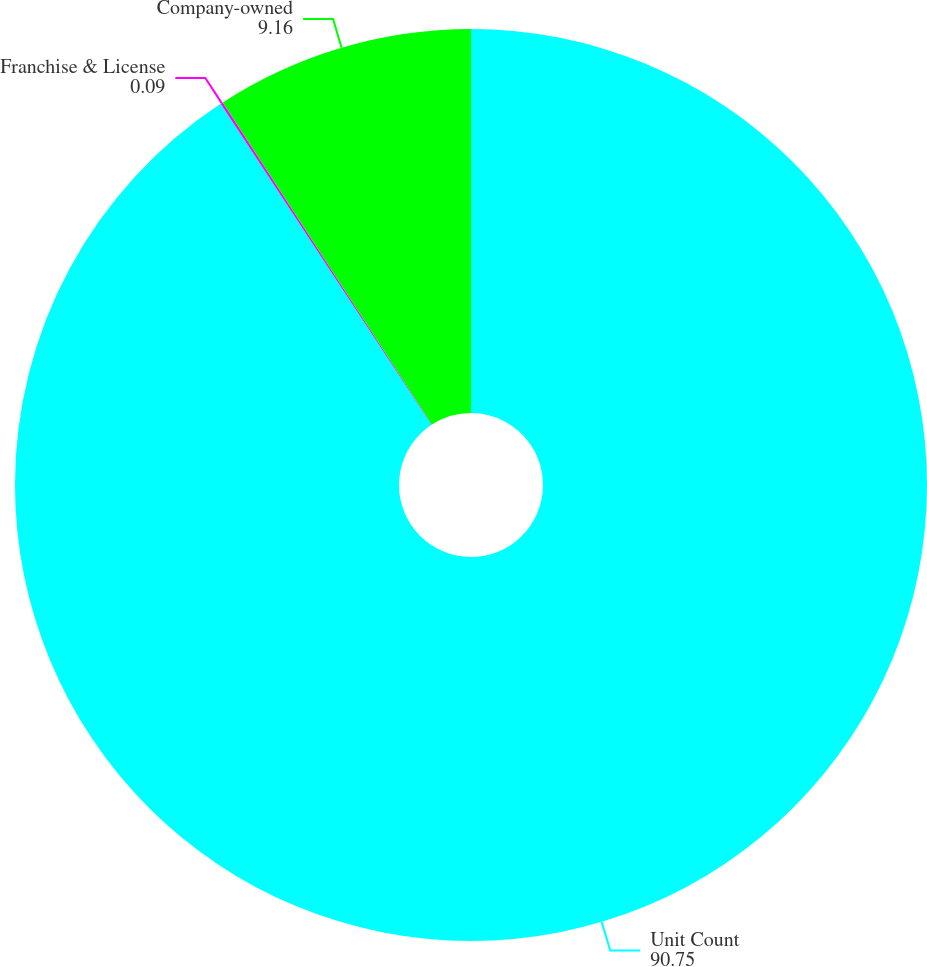Convert chart to OTSL. <chart><loc_0><loc_0><loc_500><loc_500><pie_chart><fcel>Unit Count<fcel>Franchise & License<fcel>Company-owned<nl><fcel>90.75%<fcel>0.09%<fcel>9.16%<nl></chart> 